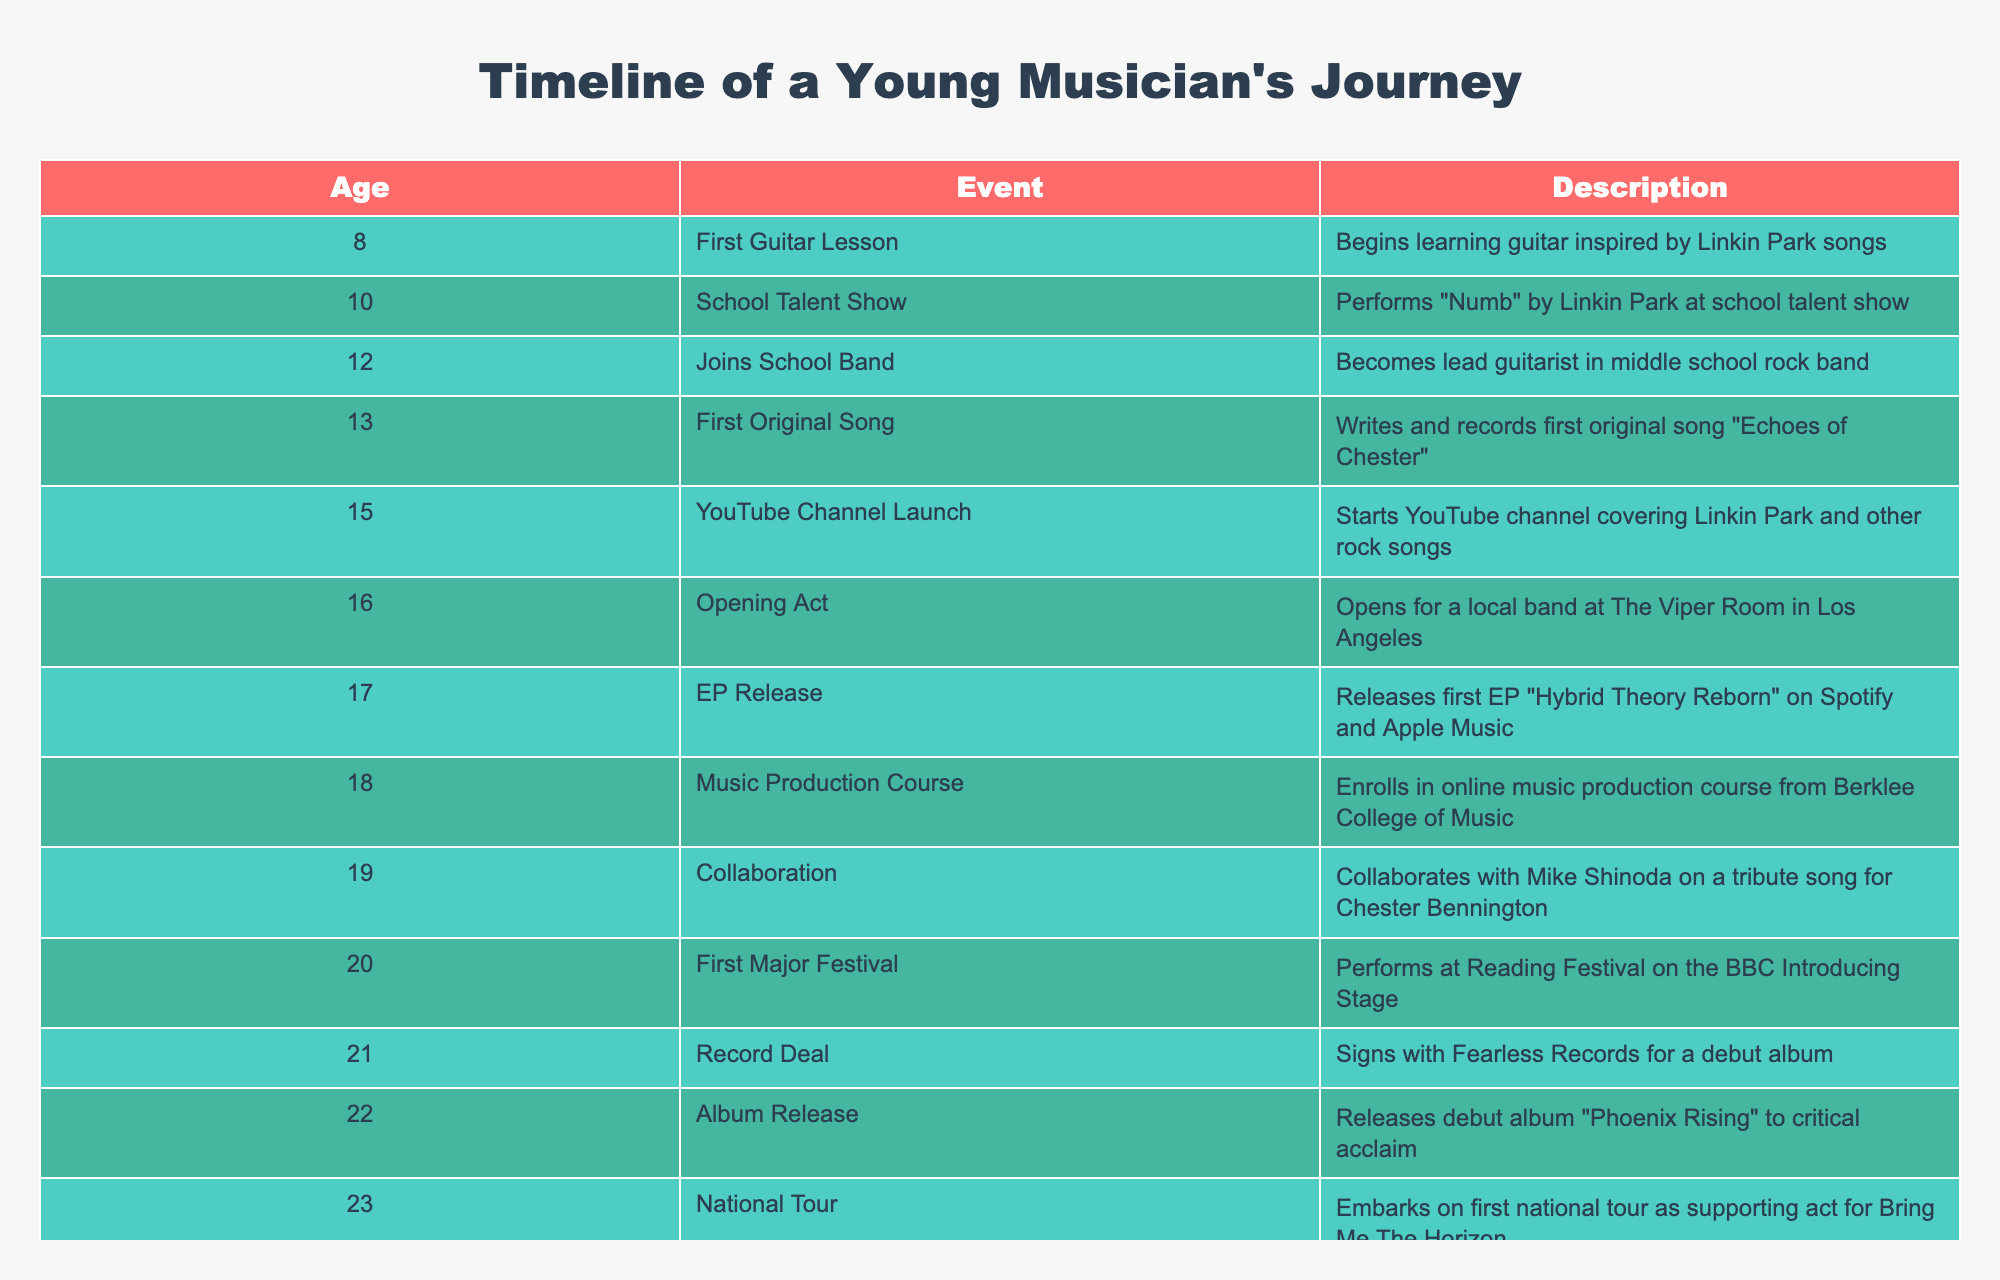What age did the musician release their first EP? According to the table, the musician released their first EP "Hybrid Theory Reborn" at the age of 17.
Answer: 17 What event occurred at age 20? At age 20, the musician performed at the Reading Festival on the BBC Introducing Stage, which is noted in the table as the first major festival performance.
Answer: Performing at the Reading Festival What were the ages when the musician completed formal music courses? The musician enrolled in an online music production course at age 18. Prior to that, there are no records of formal music courses mentioned before that age, focusing instead on performance-related achievements. So, the only age for formal music course completion is 18.
Answer: 18 Did the musician collaborate with Mike Shinoda? Yes, the table indicates that the musician collaborated with Mike Shinoda on a tribute song for Chester Bennington at age 19.
Answer: Yes What was the difference in age between the musician's first major festival performance and their EP release? The musician performed at their first major festival at age 20 and released their EP at age 17. The difference in age is 20 - 17 = 3 years.
Answer: 3 years What are the two consecutive events that occurred at ages 21 and 22? At age 21, the musician signed with Fearless Records, and at age 22, they released their debut album "Phoenix Rising." The table provides these details in consecutive rows for those ages.
Answer: Signed with Fearless Records and released debut album How many events are listed before the musician started their YouTube channel? The events listed before the YouTube channel launch at age 15 are the first guitar lesson at age 8, school talent show at age 10, joining the school band at age 12, and writing the first original song at age 13. Counting these gives a total of 4 events.
Answer: 4 events Which event marks the beginning of the musician's public performances? The musician's public performances began with the school talent show at age 10, where they performed "Numb" by Linkin Park. This is the first instance of a public performance noted in the timeline.
Answer: School talent show performance What was the highest age mentioned for any event in the timeline? The highest age mentioned in the timeline is 24, corresponding to the event of being nominated for Best New Artist. This is the last entry in the table, signifying the musician's ongoing journey.
Answer: 24 